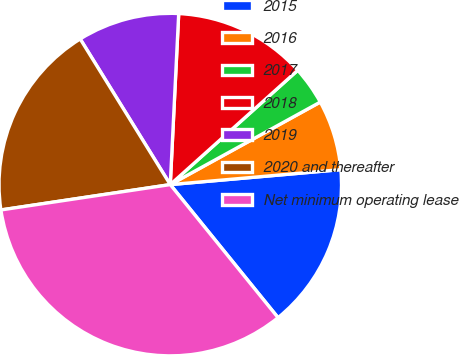<chart> <loc_0><loc_0><loc_500><loc_500><pie_chart><fcel>2015<fcel>2016<fcel>2017<fcel>2018<fcel>2019<fcel>2020 and thereafter<fcel>Net minimum operating lease<nl><fcel>15.56%<fcel>6.61%<fcel>3.63%<fcel>12.58%<fcel>9.6%<fcel>18.55%<fcel>33.47%<nl></chart> 